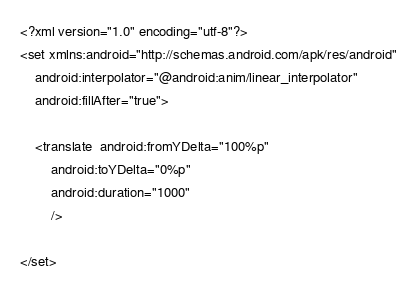Convert code to text. <code><loc_0><loc_0><loc_500><loc_500><_XML_><?xml version="1.0" encoding="utf-8"?>
<set xmlns:android="http://schemas.android.com/apk/res/android"
    android:interpolator="@android:anim/linear_interpolator"
    android:fillAfter="true">

    <translate  android:fromYDelta="100%p"
        android:toYDelta="0%p"
        android:duration="1000"
        />

</set></code> 